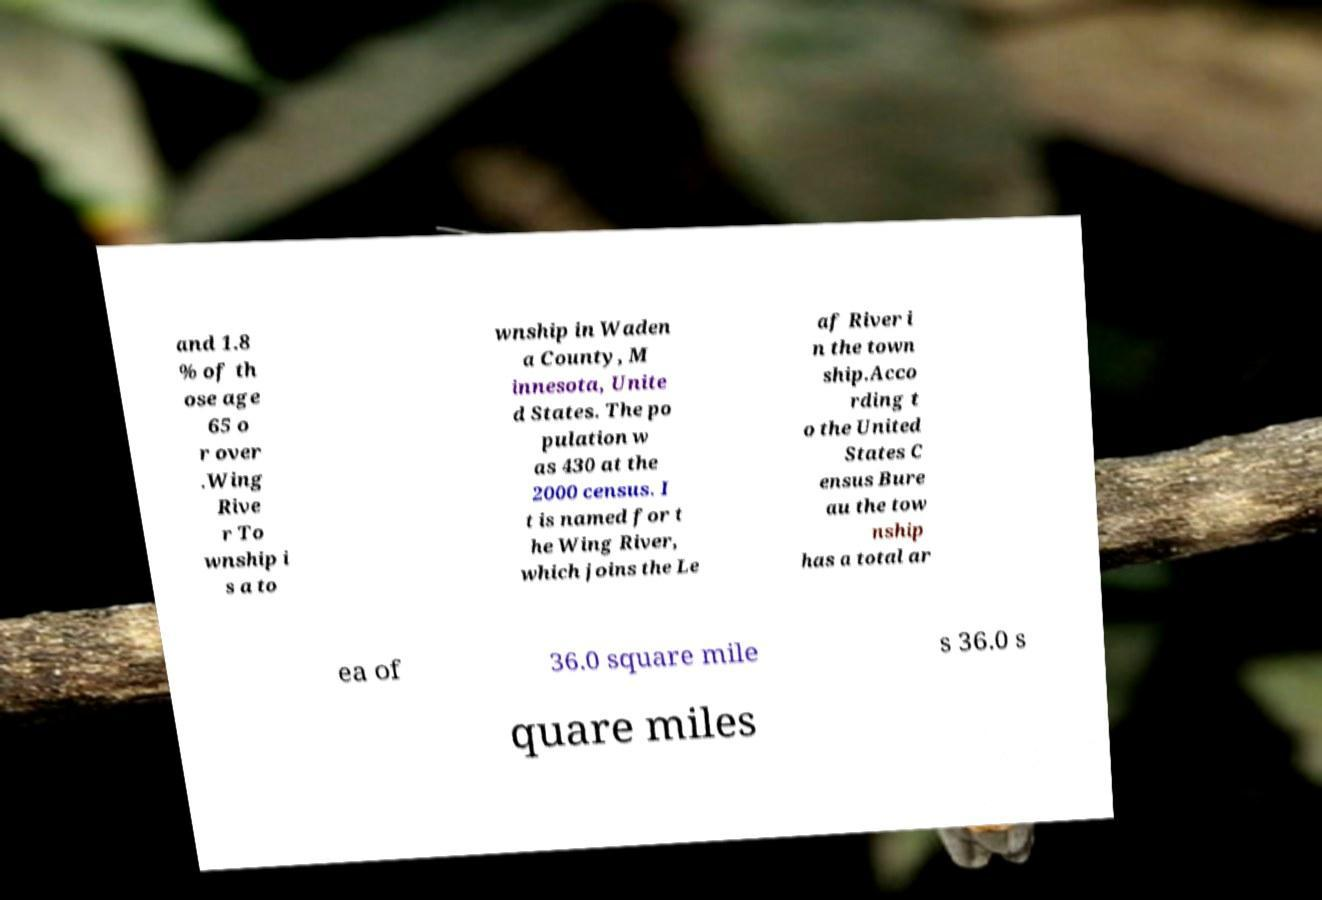For documentation purposes, I need the text within this image transcribed. Could you provide that? and 1.8 % of th ose age 65 o r over .Wing Rive r To wnship i s a to wnship in Waden a County, M innesota, Unite d States. The po pulation w as 430 at the 2000 census. I t is named for t he Wing River, which joins the Le af River i n the town ship.Acco rding t o the United States C ensus Bure au the tow nship has a total ar ea of 36.0 square mile s 36.0 s quare miles 